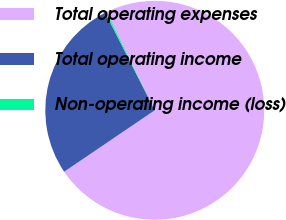Convert chart. <chart><loc_0><loc_0><loc_500><loc_500><pie_chart><fcel>Total operating expenses<fcel>Total operating income<fcel>Non-operating income (loss)<nl><fcel>72.77%<fcel>27.01%<fcel>0.22%<nl></chart> 